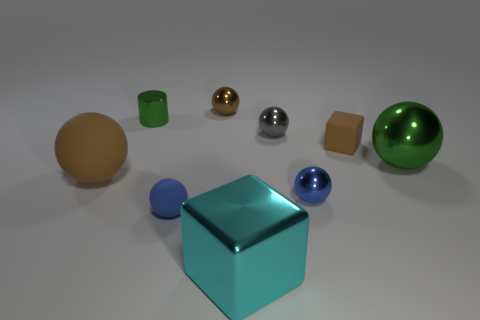Subtract all green balls. How many balls are left? 5 Subtract all blue blocks. How many blue balls are left? 2 Add 1 gray shiny balls. How many objects exist? 10 Subtract all brown spheres. How many spheres are left? 4 Subtract 1 green balls. How many objects are left? 8 Subtract all blocks. How many objects are left? 7 Subtract all blue cylinders. Subtract all yellow cubes. How many cylinders are left? 1 Subtract all brown spheres. Subtract all blue rubber objects. How many objects are left? 6 Add 1 brown metallic balls. How many brown metallic balls are left? 2 Add 2 brown rubber things. How many brown rubber things exist? 4 